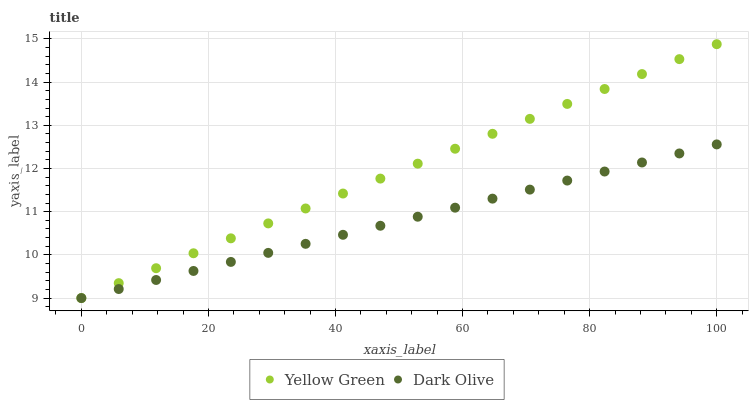Does Dark Olive have the minimum area under the curve?
Answer yes or no. Yes. Does Yellow Green have the maximum area under the curve?
Answer yes or no. Yes. Does Yellow Green have the minimum area under the curve?
Answer yes or no. No. Is Yellow Green the smoothest?
Answer yes or no. Yes. Is Dark Olive the roughest?
Answer yes or no. Yes. Is Yellow Green the roughest?
Answer yes or no. No. Does Dark Olive have the lowest value?
Answer yes or no. Yes. Does Yellow Green have the highest value?
Answer yes or no. Yes. Does Dark Olive intersect Yellow Green?
Answer yes or no. Yes. Is Dark Olive less than Yellow Green?
Answer yes or no. No. Is Dark Olive greater than Yellow Green?
Answer yes or no. No. 